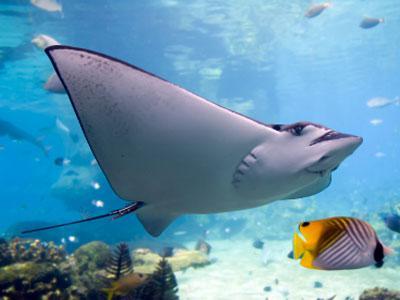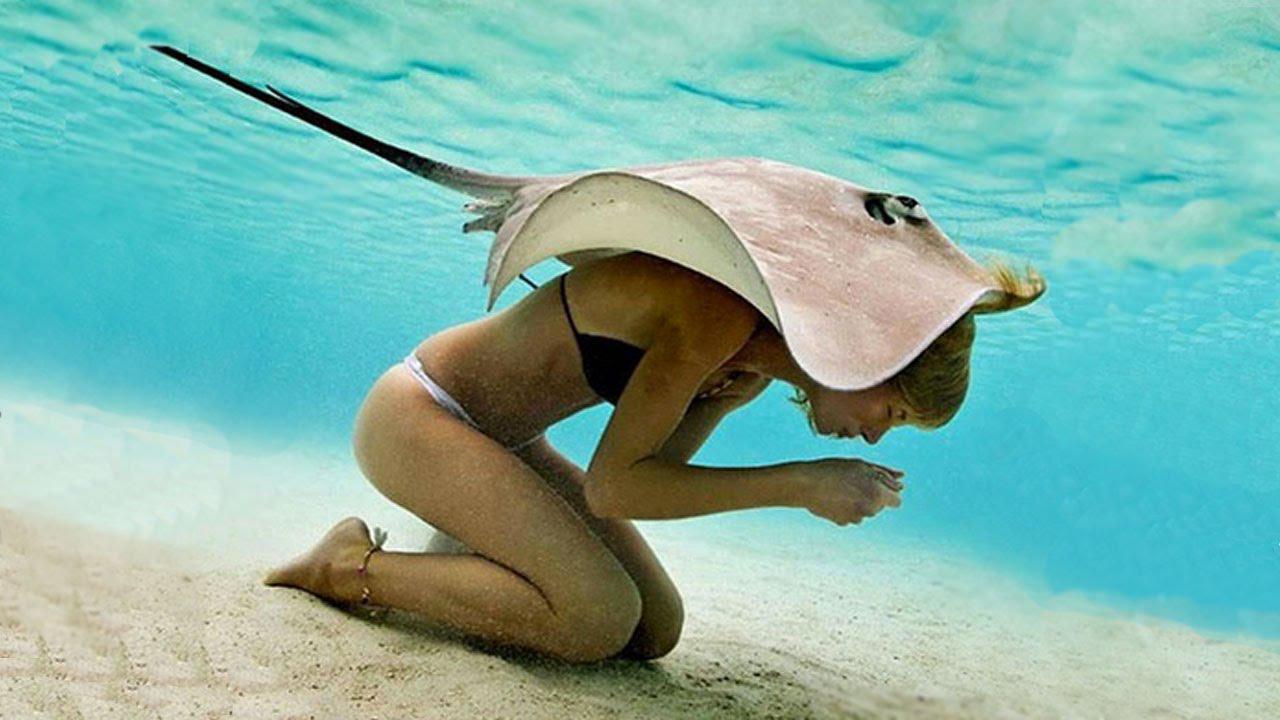The first image is the image on the left, the second image is the image on the right. Assess this claim about the two images: "The top of the ray in the image on the left is visible.". Correct or not? Answer yes or no. No. The first image is the image on the left, the second image is the image on the right. Considering the images on both sides, is "Right image shows the underbelly of a stingray, and the left shows a top-view of a stingray near the ocean bottom." valid? Answer yes or no. No. 